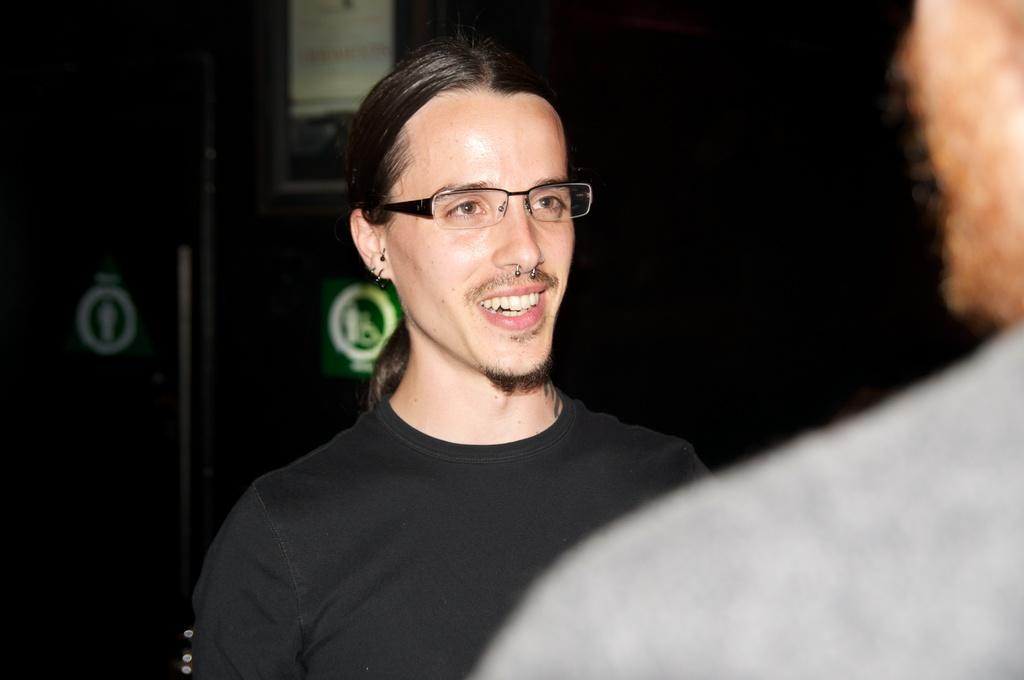How many people are in the image? There are two persons in the image. What colors are the T-shirts worn by the two people? One person is wearing a black T-shirt, and the other person is wearing a gray T-shirt. Can you describe any accessories worn by the person in the black T-shirt? The person wearing the black shirt is also wearing glasses (specs). What type of car is parked next to the person wearing the gray T-shirt? There is no car present in the image; it only features two persons. Can you tell me how many toes the person wearing the black T-shirt has? We cannot determine the number of toes the person wearing the black T-shirt has from the image alone, as it only shows the upper body. 